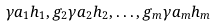<formula> <loc_0><loc_0><loc_500><loc_500>\gamma a _ { 1 } h _ { 1 } , g _ { 2 } \gamma a _ { 2 } h _ { 2 } , \dots , g _ { m } \gamma a _ { m } h _ { m }</formula> 